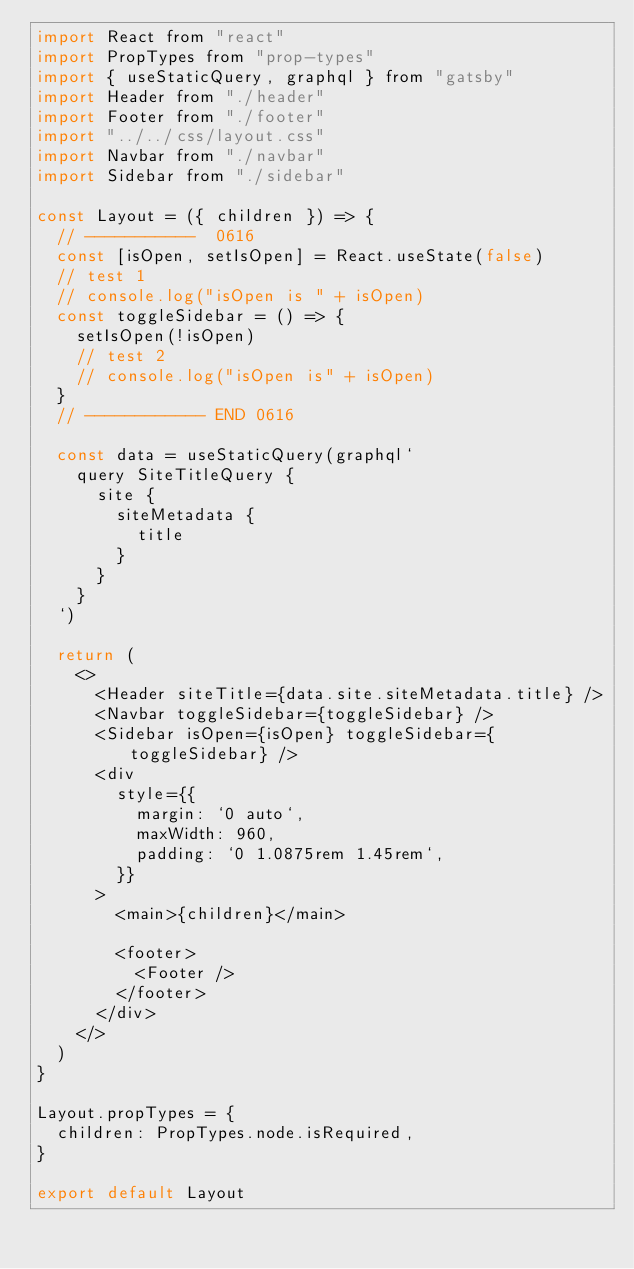Convert code to text. <code><loc_0><loc_0><loc_500><loc_500><_JavaScript_>import React from "react"
import PropTypes from "prop-types"
import { useStaticQuery, graphql } from "gatsby"
import Header from "./header"
import Footer from "./footer"
import "../../css/layout.css"
import Navbar from "./navbar"
import Sidebar from "./sidebar"

const Layout = ({ children }) => {
  // -----------  0616
  const [isOpen, setIsOpen] = React.useState(false)
  // test 1
  // console.log("isOpen is " + isOpen)
  const toggleSidebar = () => {
    setIsOpen(!isOpen)
    // test 2
    // console.log("isOpen is" + isOpen)
  }
  // ------------ END 0616

  const data = useStaticQuery(graphql`
    query SiteTitleQuery {
      site {
        siteMetadata {
          title
        }
      }
    }
  `)

  return (
    <>
      <Header siteTitle={data.site.siteMetadata.title} />
      <Navbar toggleSidebar={toggleSidebar} />
      <Sidebar isOpen={isOpen} toggleSidebar={toggleSidebar} />
      <div
        style={{
          margin: `0 auto`,
          maxWidth: 960,
          padding: `0 1.0875rem 1.45rem`,
        }}
      >
        <main>{children}</main>

        <footer>
          <Footer />
        </footer>
      </div>
    </>
  )
}

Layout.propTypes = {
  children: PropTypes.node.isRequired,
}

export default Layout
</code> 